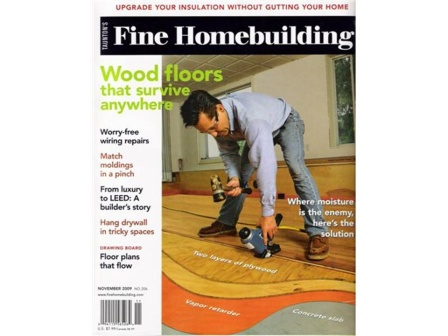Envision a scenario where the advice from the 'Where there's moisture, there's a solution' article saves the day. Consider a scenario where a homeowner discovers a persistent, damp spot on their basement wall after a heavy rainstorm. Recalling the advice from the 'Where there's moisture, there's a solution' article, they initially inspect their home's exterior drainage system, finding a clogged gutter. After clearing the blockage, they follow recommended steps to apply a waterproof sealant to the interior basement walls. The article also suggests installing a dehumidifier to manage indoor humidity levels. These proactive measures prevent the moisture problem from escalating into mold growth or structural damage, saving the homeowner significant repair costs and safeguarding their health. What are some creative solutions mentioned in the article? Some creative solutions in the article might include installing a French drain to redirect groundwater away from the foundation, using hygroscopic materials that naturally absorb and release moisture to maintain balanced indoor humidity, or integrating smart home systems that detect moisture levels and automatically control dehumidifiers and exhaust fans. Additionally, it could suggest innovative uses of moisture-resistant materials and finishes for areas prone to dampness, such as the basement or bathroom. 